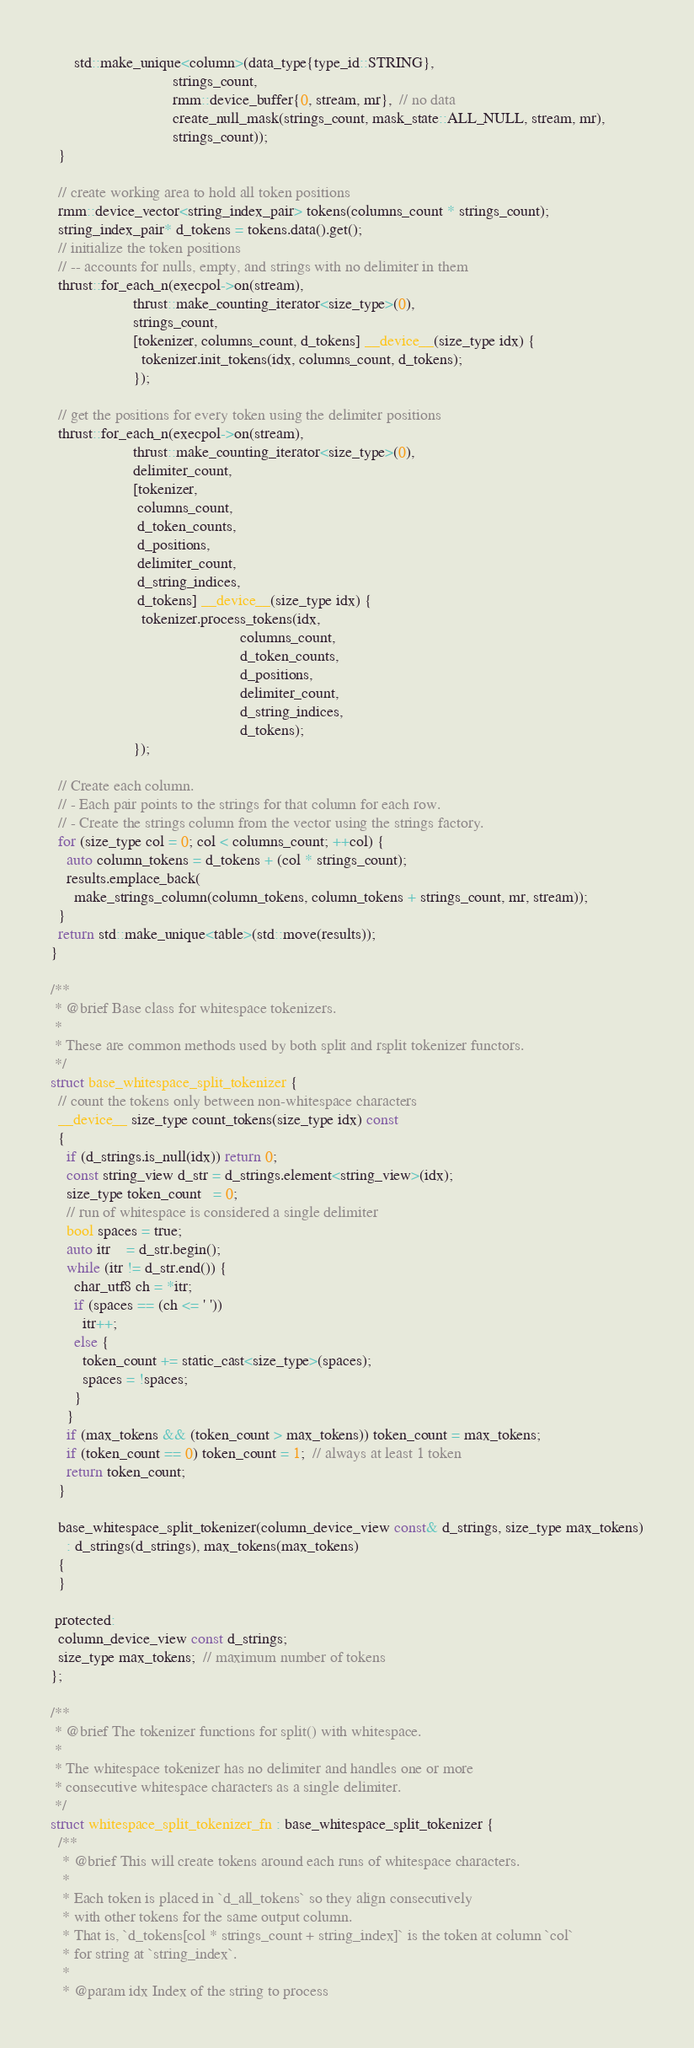<code> <loc_0><loc_0><loc_500><loc_500><_Cuda_>      std::make_unique<column>(data_type{type_id::STRING},
                               strings_count,
                               rmm::device_buffer{0, stream, mr},  // no data
                               create_null_mask(strings_count, mask_state::ALL_NULL, stream, mr),
                               strings_count));
  }

  // create working area to hold all token positions
  rmm::device_vector<string_index_pair> tokens(columns_count * strings_count);
  string_index_pair* d_tokens = tokens.data().get();
  // initialize the token positions
  // -- accounts for nulls, empty, and strings with no delimiter in them
  thrust::for_each_n(execpol->on(stream),
                     thrust::make_counting_iterator<size_type>(0),
                     strings_count,
                     [tokenizer, columns_count, d_tokens] __device__(size_type idx) {
                       tokenizer.init_tokens(idx, columns_count, d_tokens);
                     });

  // get the positions for every token using the delimiter positions
  thrust::for_each_n(execpol->on(stream),
                     thrust::make_counting_iterator<size_type>(0),
                     delimiter_count,
                     [tokenizer,
                      columns_count,
                      d_token_counts,
                      d_positions,
                      delimiter_count,
                      d_string_indices,
                      d_tokens] __device__(size_type idx) {
                       tokenizer.process_tokens(idx,
                                                columns_count,
                                                d_token_counts,
                                                d_positions,
                                                delimiter_count,
                                                d_string_indices,
                                                d_tokens);
                     });

  // Create each column.
  // - Each pair points to the strings for that column for each row.
  // - Create the strings column from the vector using the strings factory.
  for (size_type col = 0; col < columns_count; ++col) {
    auto column_tokens = d_tokens + (col * strings_count);
    results.emplace_back(
      make_strings_column(column_tokens, column_tokens + strings_count, mr, stream));
  }
  return std::make_unique<table>(std::move(results));
}

/**
 * @brief Base class for whitespace tokenizers.
 *
 * These are common methods used by both split and rsplit tokenizer functors.
 */
struct base_whitespace_split_tokenizer {
  // count the tokens only between non-whitespace characters
  __device__ size_type count_tokens(size_type idx) const
  {
    if (d_strings.is_null(idx)) return 0;
    const string_view d_str = d_strings.element<string_view>(idx);
    size_type token_count   = 0;
    // run of whitespace is considered a single delimiter
    bool spaces = true;
    auto itr    = d_str.begin();
    while (itr != d_str.end()) {
      char_utf8 ch = *itr;
      if (spaces == (ch <= ' '))
        itr++;
      else {
        token_count += static_cast<size_type>(spaces);
        spaces = !spaces;
      }
    }
    if (max_tokens && (token_count > max_tokens)) token_count = max_tokens;
    if (token_count == 0) token_count = 1;  // always at least 1 token
    return token_count;
  }

  base_whitespace_split_tokenizer(column_device_view const& d_strings, size_type max_tokens)
    : d_strings(d_strings), max_tokens(max_tokens)
  {
  }

 protected:
  column_device_view const d_strings;
  size_type max_tokens;  // maximum number of tokens
};

/**
 * @brief The tokenizer functions for split() with whitespace.
 *
 * The whitespace tokenizer has no delimiter and handles one or more
 * consecutive whitespace characters as a single delimiter.
 */
struct whitespace_split_tokenizer_fn : base_whitespace_split_tokenizer {
  /**
   * @brief This will create tokens around each runs of whitespace characters.
   *
   * Each token is placed in `d_all_tokens` so they align consecutively
   * with other tokens for the same output column.
   * That is, `d_tokens[col * strings_count + string_index]` is the token at column `col`
   * for string at `string_index`.
   *
   * @param idx Index of the string to process</code> 